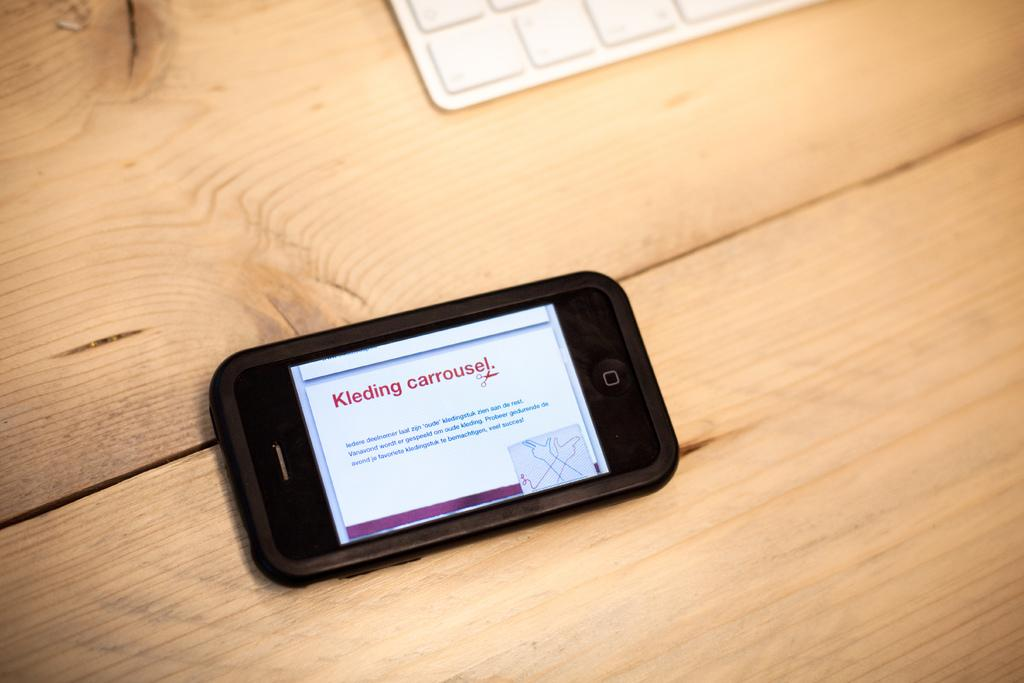<image>
Write a terse but informative summary of the picture. A cell phone screen with the text kleding carrousel typed in red. 